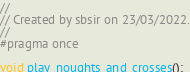Convert code to text. <code><loc_0><loc_0><loc_500><loc_500><_C_>//
// Created by sbsir on 23/03/2022.
//
#pragma once

void play_noughts_and_crosses();
</code> 